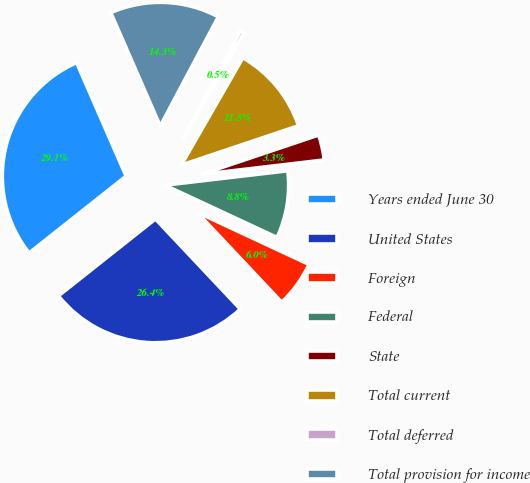Convert chart to OTSL. <chart><loc_0><loc_0><loc_500><loc_500><pie_chart><fcel>Years ended June 30<fcel>United States<fcel>Foreign<fcel>Federal<fcel>State<fcel>Total current<fcel>Total deferred<fcel>Total provision for income<nl><fcel>29.12%<fcel>26.36%<fcel>6.04%<fcel>8.8%<fcel>3.29%<fcel>11.55%<fcel>0.53%<fcel>14.31%<nl></chart> 